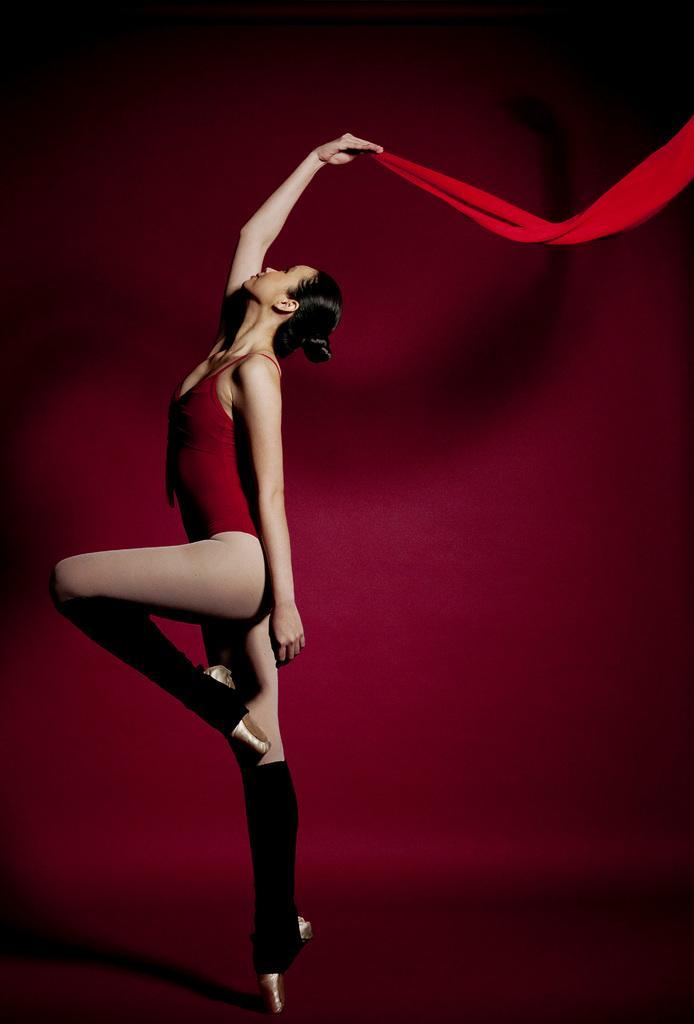How would you summarize this image in a sentence or two? In this picture there is a woman in red dress, holding a red cloth. The background is red. 